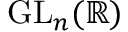<formula> <loc_0><loc_0><loc_500><loc_500>G L _ { n } ( \mathbb { R } )</formula> 